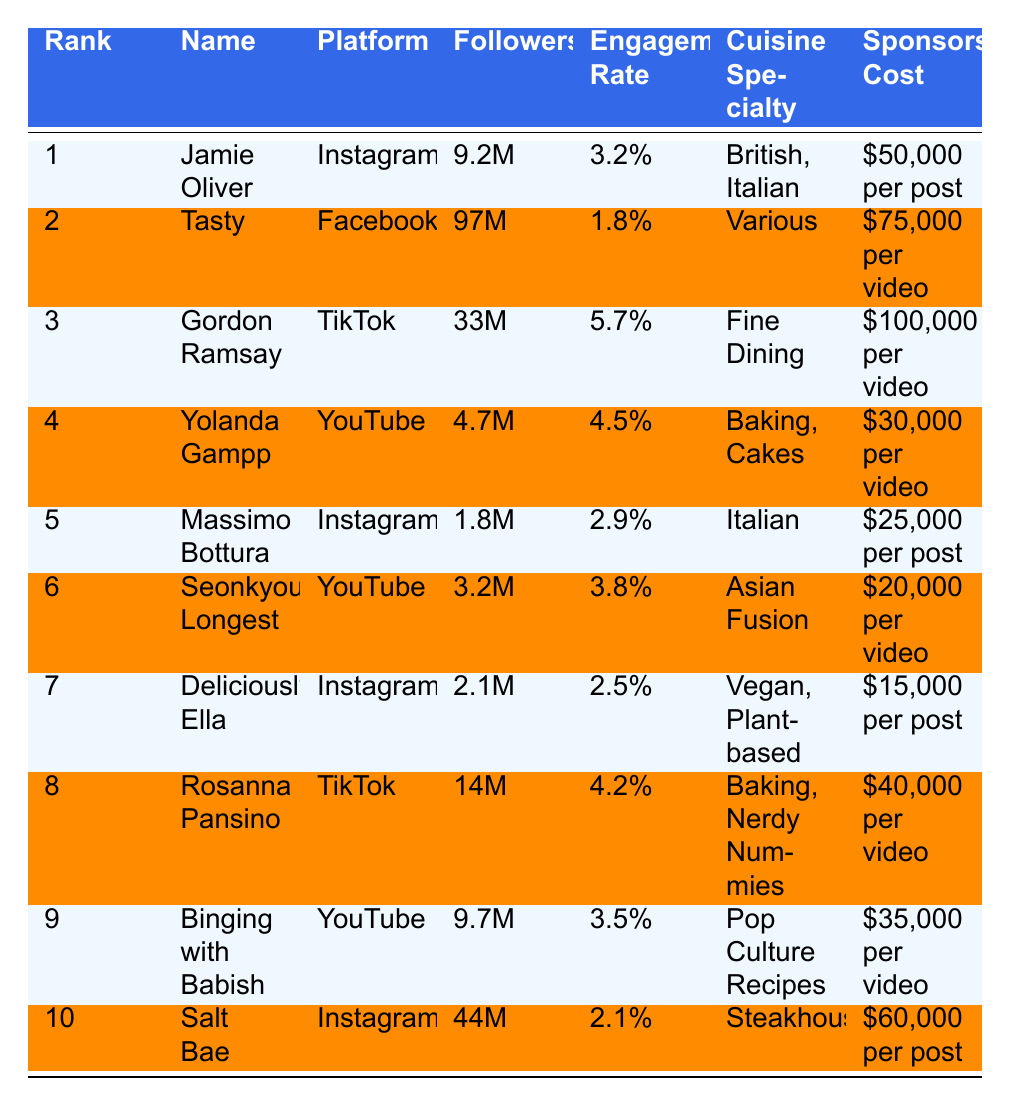What is the engagement rate of Gordon Ramsay? The table shows that Gordon Ramsay has an engagement rate of 5.7% listed next to his name under the Engagement Rate column.
Answer: 5.7% Which food influencer has the highest follower count? By comparing the Followers column, Tasty has the highest follower count at 97M.
Answer: Tasty How much does it cost to sponsor a post with Jamie Oliver? The Sponsorship Cost for Jamie Oliver is listed as $50,000 per post in the table.
Answer: $50,000 per post What is the average engagement rate of the influencers on TikTok? The TikTok influencers are Gordon Ramsay (5.7%) and Rosanna Pansino (4.2%). The average is calculated as (5.7 + 4.2) / 2 = 4.95%.
Answer: 4.95% Does Deliciously Ella have a higher engagement rate than Massimo Bottura? Deliciously Ella's engagement rate is 2.5%, while Massimo Bottura's is 2.9%. Therefore, the statement is false.
Answer: No What is the total number of followers for the influencers on Instagram? The Instagram influencers are Jamie Oliver (9.2M), Massimo Bottura (1.8M), and Salt Bae (44M). The total is 9.2 + 1.8 + 44 = 55M.
Answer: 55M Which influencer has the lowest sponsorship cost and what is it? The table lists Deliciously Ella with the lowest sponsorship cost of $15,000 per post.
Answer: $15,000 Is there any influencer on Facebook among the top 10? The table indicates that Tasty is the only influencer on Facebook. Therefore, the statement is true.
Answer: Yes What is the difference in sponsorship costs between Gordon Ramsay and Yolanda Gampp? According to the table, Gordon Ramsay's cost is $100,000 per video and Yolanda Gampp's is $30,000 per video. The difference is $100,000 - $30,000 = $70,000.
Answer: $70,000 Identify the cuisine specialty of the influencer with the second highest follower count. Tasty, with 97M followers, has a cuisine specialty listed as "Various."
Answer: Various 